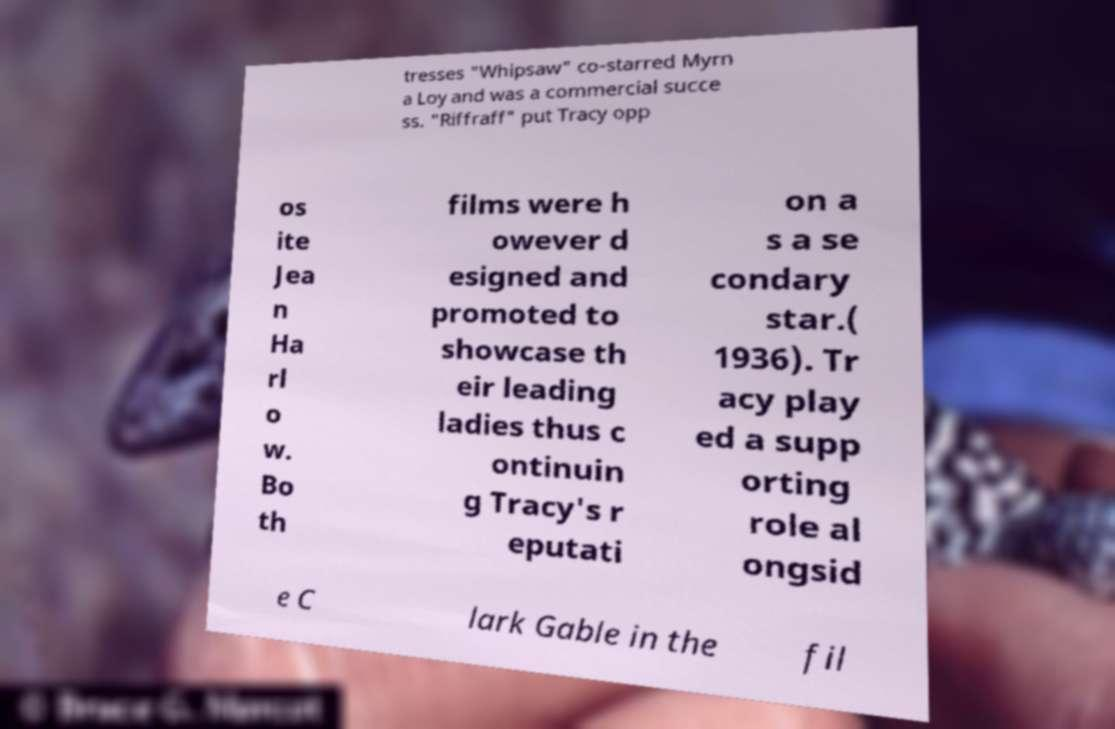Can you read and provide the text displayed in the image?This photo seems to have some interesting text. Can you extract and type it out for me? tresses "Whipsaw" co-starred Myrn a Loy and was a commercial succe ss. "Riffraff" put Tracy opp os ite Jea n Ha rl o w. Bo th films were h owever d esigned and promoted to showcase th eir leading ladies thus c ontinuin g Tracy's r eputati on a s a se condary star.( 1936). Tr acy play ed a supp orting role al ongsid e C lark Gable in the fil 